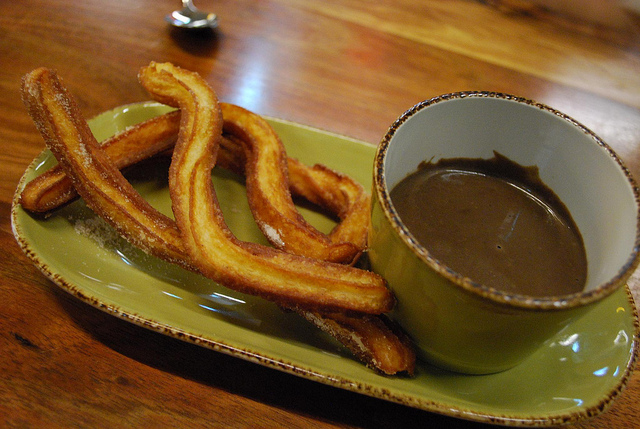What kind of food is this? This is churros, a delicious fried-dough pastry often enjoyed with a dipping sauce like chocolate. 